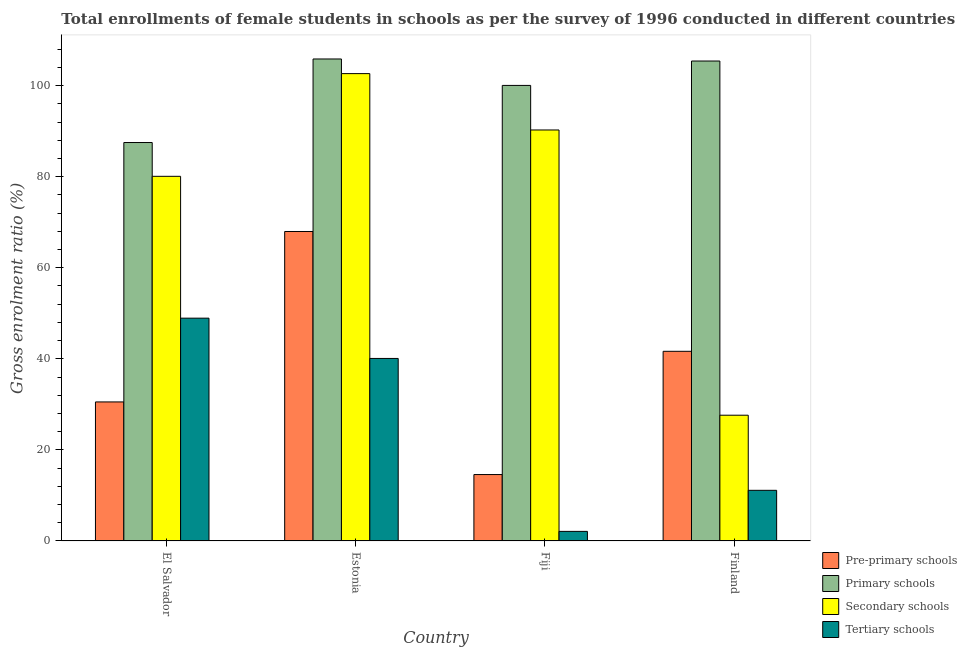How many different coloured bars are there?
Provide a short and direct response. 4. Are the number of bars on each tick of the X-axis equal?
Offer a very short reply. Yes. How many bars are there on the 1st tick from the left?
Provide a succinct answer. 4. What is the label of the 3rd group of bars from the left?
Give a very brief answer. Fiji. What is the gross enrolment ratio(female) in secondary schools in Fiji?
Keep it short and to the point. 90.26. Across all countries, what is the maximum gross enrolment ratio(female) in secondary schools?
Offer a terse response. 102.64. Across all countries, what is the minimum gross enrolment ratio(female) in primary schools?
Your response must be concise. 87.51. In which country was the gross enrolment ratio(female) in pre-primary schools maximum?
Provide a succinct answer. Estonia. In which country was the gross enrolment ratio(female) in pre-primary schools minimum?
Ensure brevity in your answer.  Fiji. What is the total gross enrolment ratio(female) in tertiary schools in the graph?
Offer a very short reply. 102.25. What is the difference between the gross enrolment ratio(female) in pre-primary schools in El Salvador and that in Fiji?
Give a very brief answer. 15.95. What is the difference between the gross enrolment ratio(female) in pre-primary schools in Fiji and the gross enrolment ratio(female) in primary schools in El Salvador?
Your answer should be compact. -72.92. What is the average gross enrolment ratio(female) in primary schools per country?
Offer a terse response. 99.71. What is the difference between the gross enrolment ratio(female) in primary schools and gross enrolment ratio(female) in secondary schools in Finland?
Your answer should be compact. 77.79. In how many countries, is the gross enrolment ratio(female) in secondary schools greater than 88 %?
Offer a very short reply. 2. What is the ratio of the gross enrolment ratio(female) in pre-primary schools in El Salvador to that in Estonia?
Provide a succinct answer. 0.45. Is the gross enrolment ratio(female) in pre-primary schools in Estonia less than that in Fiji?
Make the answer very short. No. Is the difference between the gross enrolment ratio(female) in pre-primary schools in Estonia and Fiji greater than the difference between the gross enrolment ratio(female) in tertiary schools in Estonia and Fiji?
Provide a short and direct response. Yes. What is the difference between the highest and the second highest gross enrolment ratio(female) in primary schools?
Offer a very short reply. 0.45. What is the difference between the highest and the lowest gross enrolment ratio(female) in tertiary schools?
Offer a terse response. 46.83. What does the 2nd bar from the left in Finland represents?
Provide a succinct answer. Primary schools. What does the 2nd bar from the right in Finland represents?
Your answer should be compact. Secondary schools. Is it the case that in every country, the sum of the gross enrolment ratio(female) in pre-primary schools and gross enrolment ratio(female) in primary schools is greater than the gross enrolment ratio(female) in secondary schools?
Offer a very short reply. Yes. How many countries are there in the graph?
Give a very brief answer. 4. Are the values on the major ticks of Y-axis written in scientific E-notation?
Your answer should be compact. No. What is the title of the graph?
Give a very brief answer. Total enrollments of female students in schools as per the survey of 1996 conducted in different countries. What is the Gross enrolment ratio (%) of Pre-primary schools in El Salvador?
Offer a terse response. 30.54. What is the Gross enrolment ratio (%) of Primary schools in El Salvador?
Make the answer very short. 87.51. What is the Gross enrolment ratio (%) in Secondary schools in El Salvador?
Offer a terse response. 80.09. What is the Gross enrolment ratio (%) in Tertiary schools in El Salvador?
Provide a succinct answer. 48.94. What is the Gross enrolment ratio (%) of Pre-primary schools in Estonia?
Provide a succinct answer. 67.97. What is the Gross enrolment ratio (%) in Primary schools in Estonia?
Provide a succinct answer. 105.86. What is the Gross enrolment ratio (%) of Secondary schools in Estonia?
Make the answer very short. 102.64. What is the Gross enrolment ratio (%) in Tertiary schools in Estonia?
Your response must be concise. 40.09. What is the Gross enrolment ratio (%) in Pre-primary schools in Fiji?
Provide a succinct answer. 14.59. What is the Gross enrolment ratio (%) of Primary schools in Fiji?
Your answer should be very brief. 100.05. What is the Gross enrolment ratio (%) in Secondary schools in Fiji?
Keep it short and to the point. 90.26. What is the Gross enrolment ratio (%) of Tertiary schools in Fiji?
Provide a succinct answer. 2.11. What is the Gross enrolment ratio (%) in Pre-primary schools in Finland?
Your answer should be compact. 41.65. What is the Gross enrolment ratio (%) in Primary schools in Finland?
Your answer should be very brief. 105.41. What is the Gross enrolment ratio (%) in Secondary schools in Finland?
Keep it short and to the point. 27.62. What is the Gross enrolment ratio (%) in Tertiary schools in Finland?
Offer a terse response. 11.12. Across all countries, what is the maximum Gross enrolment ratio (%) of Pre-primary schools?
Keep it short and to the point. 67.97. Across all countries, what is the maximum Gross enrolment ratio (%) in Primary schools?
Your answer should be compact. 105.86. Across all countries, what is the maximum Gross enrolment ratio (%) in Secondary schools?
Offer a terse response. 102.64. Across all countries, what is the maximum Gross enrolment ratio (%) in Tertiary schools?
Keep it short and to the point. 48.94. Across all countries, what is the minimum Gross enrolment ratio (%) of Pre-primary schools?
Offer a terse response. 14.59. Across all countries, what is the minimum Gross enrolment ratio (%) of Primary schools?
Provide a short and direct response. 87.51. Across all countries, what is the minimum Gross enrolment ratio (%) in Secondary schools?
Ensure brevity in your answer.  27.62. Across all countries, what is the minimum Gross enrolment ratio (%) of Tertiary schools?
Offer a terse response. 2.11. What is the total Gross enrolment ratio (%) in Pre-primary schools in the graph?
Offer a very short reply. 154.75. What is the total Gross enrolment ratio (%) in Primary schools in the graph?
Your response must be concise. 398.83. What is the total Gross enrolment ratio (%) of Secondary schools in the graph?
Your answer should be very brief. 300.61. What is the total Gross enrolment ratio (%) in Tertiary schools in the graph?
Keep it short and to the point. 102.25. What is the difference between the Gross enrolment ratio (%) in Pre-primary schools in El Salvador and that in Estonia?
Ensure brevity in your answer.  -37.43. What is the difference between the Gross enrolment ratio (%) of Primary schools in El Salvador and that in Estonia?
Keep it short and to the point. -18.35. What is the difference between the Gross enrolment ratio (%) of Secondary schools in El Salvador and that in Estonia?
Offer a very short reply. -22.56. What is the difference between the Gross enrolment ratio (%) in Tertiary schools in El Salvador and that in Estonia?
Ensure brevity in your answer.  8.85. What is the difference between the Gross enrolment ratio (%) of Pre-primary schools in El Salvador and that in Fiji?
Offer a very short reply. 15.95. What is the difference between the Gross enrolment ratio (%) in Primary schools in El Salvador and that in Fiji?
Your answer should be very brief. -12.54. What is the difference between the Gross enrolment ratio (%) of Secondary schools in El Salvador and that in Fiji?
Make the answer very short. -10.18. What is the difference between the Gross enrolment ratio (%) of Tertiary schools in El Salvador and that in Fiji?
Offer a very short reply. 46.83. What is the difference between the Gross enrolment ratio (%) in Pre-primary schools in El Salvador and that in Finland?
Your response must be concise. -11.12. What is the difference between the Gross enrolment ratio (%) of Primary schools in El Salvador and that in Finland?
Keep it short and to the point. -17.9. What is the difference between the Gross enrolment ratio (%) of Secondary schools in El Salvador and that in Finland?
Keep it short and to the point. 52.47. What is the difference between the Gross enrolment ratio (%) in Tertiary schools in El Salvador and that in Finland?
Give a very brief answer. 37.81. What is the difference between the Gross enrolment ratio (%) in Pre-primary schools in Estonia and that in Fiji?
Provide a succinct answer. 53.38. What is the difference between the Gross enrolment ratio (%) in Primary schools in Estonia and that in Fiji?
Your answer should be very brief. 5.81. What is the difference between the Gross enrolment ratio (%) in Secondary schools in Estonia and that in Fiji?
Provide a short and direct response. 12.38. What is the difference between the Gross enrolment ratio (%) in Tertiary schools in Estonia and that in Fiji?
Ensure brevity in your answer.  37.98. What is the difference between the Gross enrolment ratio (%) of Pre-primary schools in Estonia and that in Finland?
Offer a terse response. 26.32. What is the difference between the Gross enrolment ratio (%) in Primary schools in Estonia and that in Finland?
Provide a short and direct response. 0.45. What is the difference between the Gross enrolment ratio (%) of Secondary schools in Estonia and that in Finland?
Offer a terse response. 75.02. What is the difference between the Gross enrolment ratio (%) in Tertiary schools in Estonia and that in Finland?
Provide a succinct answer. 28.96. What is the difference between the Gross enrolment ratio (%) of Pre-primary schools in Fiji and that in Finland?
Provide a short and direct response. -27.07. What is the difference between the Gross enrolment ratio (%) in Primary schools in Fiji and that in Finland?
Your answer should be very brief. -5.36. What is the difference between the Gross enrolment ratio (%) in Secondary schools in Fiji and that in Finland?
Ensure brevity in your answer.  62.64. What is the difference between the Gross enrolment ratio (%) of Tertiary schools in Fiji and that in Finland?
Make the answer very short. -9.02. What is the difference between the Gross enrolment ratio (%) in Pre-primary schools in El Salvador and the Gross enrolment ratio (%) in Primary schools in Estonia?
Provide a succinct answer. -75.32. What is the difference between the Gross enrolment ratio (%) of Pre-primary schools in El Salvador and the Gross enrolment ratio (%) of Secondary schools in Estonia?
Ensure brevity in your answer.  -72.11. What is the difference between the Gross enrolment ratio (%) in Pre-primary schools in El Salvador and the Gross enrolment ratio (%) in Tertiary schools in Estonia?
Give a very brief answer. -9.55. What is the difference between the Gross enrolment ratio (%) of Primary schools in El Salvador and the Gross enrolment ratio (%) of Secondary schools in Estonia?
Keep it short and to the point. -15.13. What is the difference between the Gross enrolment ratio (%) of Primary schools in El Salvador and the Gross enrolment ratio (%) of Tertiary schools in Estonia?
Make the answer very short. 47.42. What is the difference between the Gross enrolment ratio (%) of Secondary schools in El Salvador and the Gross enrolment ratio (%) of Tertiary schools in Estonia?
Give a very brief answer. 40. What is the difference between the Gross enrolment ratio (%) in Pre-primary schools in El Salvador and the Gross enrolment ratio (%) in Primary schools in Fiji?
Your response must be concise. -69.51. What is the difference between the Gross enrolment ratio (%) of Pre-primary schools in El Salvador and the Gross enrolment ratio (%) of Secondary schools in Fiji?
Your response must be concise. -59.73. What is the difference between the Gross enrolment ratio (%) of Pre-primary schools in El Salvador and the Gross enrolment ratio (%) of Tertiary schools in Fiji?
Your answer should be very brief. 28.43. What is the difference between the Gross enrolment ratio (%) in Primary schools in El Salvador and the Gross enrolment ratio (%) in Secondary schools in Fiji?
Your response must be concise. -2.75. What is the difference between the Gross enrolment ratio (%) of Primary schools in El Salvador and the Gross enrolment ratio (%) of Tertiary schools in Fiji?
Your response must be concise. 85.4. What is the difference between the Gross enrolment ratio (%) in Secondary schools in El Salvador and the Gross enrolment ratio (%) in Tertiary schools in Fiji?
Provide a succinct answer. 77.98. What is the difference between the Gross enrolment ratio (%) in Pre-primary schools in El Salvador and the Gross enrolment ratio (%) in Primary schools in Finland?
Keep it short and to the point. -74.87. What is the difference between the Gross enrolment ratio (%) in Pre-primary schools in El Salvador and the Gross enrolment ratio (%) in Secondary schools in Finland?
Provide a succinct answer. 2.92. What is the difference between the Gross enrolment ratio (%) in Pre-primary schools in El Salvador and the Gross enrolment ratio (%) in Tertiary schools in Finland?
Make the answer very short. 19.41. What is the difference between the Gross enrolment ratio (%) of Primary schools in El Salvador and the Gross enrolment ratio (%) of Secondary schools in Finland?
Your answer should be compact. 59.89. What is the difference between the Gross enrolment ratio (%) of Primary schools in El Salvador and the Gross enrolment ratio (%) of Tertiary schools in Finland?
Provide a short and direct response. 76.39. What is the difference between the Gross enrolment ratio (%) in Secondary schools in El Salvador and the Gross enrolment ratio (%) in Tertiary schools in Finland?
Make the answer very short. 68.96. What is the difference between the Gross enrolment ratio (%) in Pre-primary schools in Estonia and the Gross enrolment ratio (%) in Primary schools in Fiji?
Provide a short and direct response. -32.08. What is the difference between the Gross enrolment ratio (%) of Pre-primary schools in Estonia and the Gross enrolment ratio (%) of Secondary schools in Fiji?
Provide a succinct answer. -22.3. What is the difference between the Gross enrolment ratio (%) of Pre-primary schools in Estonia and the Gross enrolment ratio (%) of Tertiary schools in Fiji?
Provide a short and direct response. 65.86. What is the difference between the Gross enrolment ratio (%) in Primary schools in Estonia and the Gross enrolment ratio (%) in Secondary schools in Fiji?
Your response must be concise. 15.59. What is the difference between the Gross enrolment ratio (%) in Primary schools in Estonia and the Gross enrolment ratio (%) in Tertiary schools in Fiji?
Keep it short and to the point. 103.75. What is the difference between the Gross enrolment ratio (%) in Secondary schools in Estonia and the Gross enrolment ratio (%) in Tertiary schools in Fiji?
Make the answer very short. 100.54. What is the difference between the Gross enrolment ratio (%) in Pre-primary schools in Estonia and the Gross enrolment ratio (%) in Primary schools in Finland?
Provide a short and direct response. -37.44. What is the difference between the Gross enrolment ratio (%) in Pre-primary schools in Estonia and the Gross enrolment ratio (%) in Secondary schools in Finland?
Keep it short and to the point. 40.35. What is the difference between the Gross enrolment ratio (%) of Pre-primary schools in Estonia and the Gross enrolment ratio (%) of Tertiary schools in Finland?
Your answer should be compact. 56.85. What is the difference between the Gross enrolment ratio (%) of Primary schools in Estonia and the Gross enrolment ratio (%) of Secondary schools in Finland?
Keep it short and to the point. 78.24. What is the difference between the Gross enrolment ratio (%) in Primary schools in Estonia and the Gross enrolment ratio (%) in Tertiary schools in Finland?
Your answer should be compact. 94.73. What is the difference between the Gross enrolment ratio (%) of Secondary schools in Estonia and the Gross enrolment ratio (%) of Tertiary schools in Finland?
Provide a short and direct response. 91.52. What is the difference between the Gross enrolment ratio (%) in Pre-primary schools in Fiji and the Gross enrolment ratio (%) in Primary schools in Finland?
Give a very brief answer. -90.82. What is the difference between the Gross enrolment ratio (%) in Pre-primary schools in Fiji and the Gross enrolment ratio (%) in Secondary schools in Finland?
Ensure brevity in your answer.  -13.03. What is the difference between the Gross enrolment ratio (%) of Pre-primary schools in Fiji and the Gross enrolment ratio (%) of Tertiary schools in Finland?
Provide a short and direct response. 3.47. What is the difference between the Gross enrolment ratio (%) in Primary schools in Fiji and the Gross enrolment ratio (%) in Secondary schools in Finland?
Keep it short and to the point. 72.43. What is the difference between the Gross enrolment ratio (%) of Primary schools in Fiji and the Gross enrolment ratio (%) of Tertiary schools in Finland?
Your answer should be compact. 88.93. What is the difference between the Gross enrolment ratio (%) in Secondary schools in Fiji and the Gross enrolment ratio (%) in Tertiary schools in Finland?
Ensure brevity in your answer.  79.14. What is the average Gross enrolment ratio (%) in Pre-primary schools per country?
Offer a terse response. 38.69. What is the average Gross enrolment ratio (%) of Primary schools per country?
Give a very brief answer. 99.71. What is the average Gross enrolment ratio (%) of Secondary schools per country?
Provide a short and direct response. 75.15. What is the average Gross enrolment ratio (%) of Tertiary schools per country?
Provide a succinct answer. 25.56. What is the difference between the Gross enrolment ratio (%) in Pre-primary schools and Gross enrolment ratio (%) in Primary schools in El Salvador?
Make the answer very short. -56.97. What is the difference between the Gross enrolment ratio (%) in Pre-primary schools and Gross enrolment ratio (%) in Secondary schools in El Salvador?
Ensure brevity in your answer.  -49.55. What is the difference between the Gross enrolment ratio (%) of Pre-primary schools and Gross enrolment ratio (%) of Tertiary schools in El Salvador?
Offer a very short reply. -18.4. What is the difference between the Gross enrolment ratio (%) in Primary schools and Gross enrolment ratio (%) in Secondary schools in El Salvador?
Your answer should be compact. 7.42. What is the difference between the Gross enrolment ratio (%) in Primary schools and Gross enrolment ratio (%) in Tertiary schools in El Salvador?
Provide a succinct answer. 38.57. What is the difference between the Gross enrolment ratio (%) of Secondary schools and Gross enrolment ratio (%) of Tertiary schools in El Salvador?
Make the answer very short. 31.15. What is the difference between the Gross enrolment ratio (%) of Pre-primary schools and Gross enrolment ratio (%) of Primary schools in Estonia?
Provide a succinct answer. -37.89. What is the difference between the Gross enrolment ratio (%) of Pre-primary schools and Gross enrolment ratio (%) of Secondary schools in Estonia?
Provide a short and direct response. -34.67. What is the difference between the Gross enrolment ratio (%) in Pre-primary schools and Gross enrolment ratio (%) in Tertiary schools in Estonia?
Offer a terse response. 27.88. What is the difference between the Gross enrolment ratio (%) of Primary schools and Gross enrolment ratio (%) of Secondary schools in Estonia?
Make the answer very short. 3.21. What is the difference between the Gross enrolment ratio (%) of Primary schools and Gross enrolment ratio (%) of Tertiary schools in Estonia?
Provide a succinct answer. 65.77. What is the difference between the Gross enrolment ratio (%) of Secondary schools and Gross enrolment ratio (%) of Tertiary schools in Estonia?
Offer a very short reply. 62.55. What is the difference between the Gross enrolment ratio (%) in Pre-primary schools and Gross enrolment ratio (%) in Primary schools in Fiji?
Your response must be concise. -85.46. What is the difference between the Gross enrolment ratio (%) in Pre-primary schools and Gross enrolment ratio (%) in Secondary schools in Fiji?
Offer a terse response. -75.68. What is the difference between the Gross enrolment ratio (%) of Pre-primary schools and Gross enrolment ratio (%) of Tertiary schools in Fiji?
Keep it short and to the point. 12.48. What is the difference between the Gross enrolment ratio (%) in Primary schools and Gross enrolment ratio (%) in Secondary schools in Fiji?
Keep it short and to the point. 9.79. What is the difference between the Gross enrolment ratio (%) of Primary schools and Gross enrolment ratio (%) of Tertiary schools in Fiji?
Give a very brief answer. 97.95. What is the difference between the Gross enrolment ratio (%) in Secondary schools and Gross enrolment ratio (%) in Tertiary schools in Fiji?
Your response must be concise. 88.16. What is the difference between the Gross enrolment ratio (%) in Pre-primary schools and Gross enrolment ratio (%) in Primary schools in Finland?
Offer a terse response. -63.75. What is the difference between the Gross enrolment ratio (%) of Pre-primary schools and Gross enrolment ratio (%) of Secondary schools in Finland?
Make the answer very short. 14.03. What is the difference between the Gross enrolment ratio (%) in Pre-primary schools and Gross enrolment ratio (%) in Tertiary schools in Finland?
Ensure brevity in your answer.  30.53. What is the difference between the Gross enrolment ratio (%) in Primary schools and Gross enrolment ratio (%) in Secondary schools in Finland?
Make the answer very short. 77.79. What is the difference between the Gross enrolment ratio (%) of Primary schools and Gross enrolment ratio (%) of Tertiary schools in Finland?
Offer a terse response. 94.28. What is the difference between the Gross enrolment ratio (%) in Secondary schools and Gross enrolment ratio (%) in Tertiary schools in Finland?
Offer a terse response. 16.5. What is the ratio of the Gross enrolment ratio (%) in Pre-primary schools in El Salvador to that in Estonia?
Ensure brevity in your answer.  0.45. What is the ratio of the Gross enrolment ratio (%) in Primary schools in El Salvador to that in Estonia?
Ensure brevity in your answer.  0.83. What is the ratio of the Gross enrolment ratio (%) of Secondary schools in El Salvador to that in Estonia?
Give a very brief answer. 0.78. What is the ratio of the Gross enrolment ratio (%) in Tertiary schools in El Salvador to that in Estonia?
Your answer should be very brief. 1.22. What is the ratio of the Gross enrolment ratio (%) of Pre-primary schools in El Salvador to that in Fiji?
Your answer should be very brief. 2.09. What is the ratio of the Gross enrolment ratio (%) of Primary schools in El Salvador to that in Fiji?
Offer a very short reply. 0.87. What is the ratio of the Gross enrolment ratio (%) in Secondary schools in El Salvador to that in Fiji?
Provide a short and direct response. 0.89. What is the ratio of the Gross enrolment ratio (%) of Tertiary schools in El Salvador to that in Fiji?
Give a very brief answer. 23.24. What is the ratio of the Gross enrolment ratio (%) of Pre-primary schools in El Salvador to that in Finland?
Offer a very short reply. 0.73. What is the ratio of the Gross enrolment ratio (%) of Primary schools in El Salvador to that in Finland?
Offer a terse response. 0.83. What is the ratio of the Gross enrolment ratio (%) of Secondary schools in El Salvador to that in Finland?
Your answer should be compact. 2.9. What is the ratio of the Gross enrolment ratio (%) of Tertiary schools in El Salvador to that in Finland?
Ensure brevity in your answer.  4.4. What is the ratio of the Gross enrolment ratio (%) in Pre-primary schools in Estonia to that in Fiji?
Keep it short and to the point. 4.66. What is the ratio of the Gross enrolment ratio (%) in Primary schools in Estonia to that in Fiji?
Give a very brief answer. 1.06. What is the ratio of the Gross enrolment ratio (%) in Secondary schools in Estonia to that in Fiji?
Your response must be concise. 1.14. What is the ratio of the Gross enrolment ratio (%) in Tertiary schools in Estonia to that in Fiji?
Offer a terse response. 19.04. What is the ratio of the Gross enrolment ratio (%) of Pre-primary schools in Estonia to that in Finland?
Your answer should be compact. 1.63. What is the ratio of the Gross enrolment ratio (%) in Primary schools in Estonia to that in Finland?
Your response must be concise. 1. What is the ratio of the Gross enrolment ratio (%) of Secondary schools in Estonia to that in Finland?
Your answer should be compact. 3.72. What is the ratio of the Gross enrolment ratio (%) in Tertiary schools in Estonia to that in Finland?
Offer a very short reply. 3.6. What is the ratio of the Gross enrolment ratio (%) of Pre-primary schools in Fiji to that in Finland?
Your answer should be compact. 0.35. What is the ratio of the Gross enrolment ratio (%) in Primary schools in Fiji to that in Finland?
Your answer should be compact. 0.95. What is the ratio of the Gross enrolment ratio (%) in Secondary schools in Fiji to that in Finland?
Offer a terse response. 3.27. What is the ratio of the Gross enrolment ratio (%) in Tertiary schools in Fiji to that in Finland?
Ensure brevity in your answer.  0.19. What is the difference between the highest and the second highest Gross enrolment ratio (%) in Pre-primary schools?
Your answer should be very brief. 26.32. What is the difference between the highest and the second highest Gross enrolment ratio (%) of Primary schools?
Offer a very short reply. 0.45. What is the difference between the highest and the second highest Gross enrolment ratio (%) in Secondary schools?
Make the answer very short. 12.38. What is the difference between the highest and the second highest Gross enrolment ratio (%) of Tertiary schools?
Your answer should be very brief. 8.85. What is the difference between the highest and the lowest Gross enrolment ratio (%) in Pre-primary schools?
Your response must be concise. 53.38. What is the difference between the highest and the lowest Gross enrolment ratio (%) of Primary schools?
Your answer should be compact. 18.35. What is the difference between the highest and the lowest Gross enrolment ratio (%) of Secondary schools?
Your response must be concise. 75.02. What is the difference between the highest and the lowest Gross enrolment ratio (%) of Tertiary schools?
Your response must be concise. 46.83. 